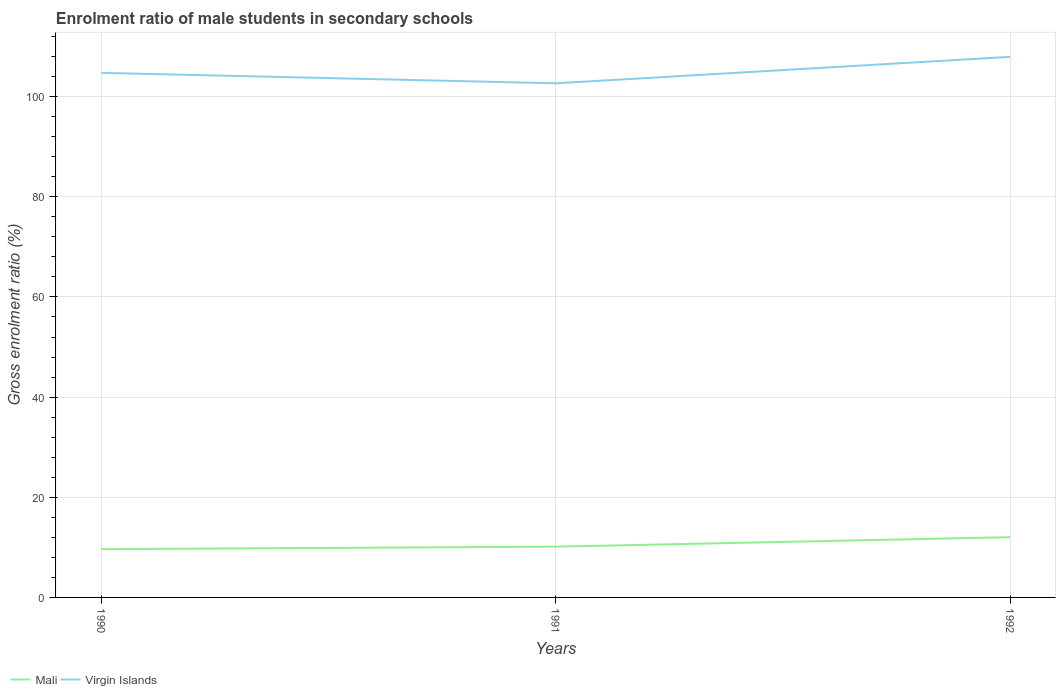How many different coloured lines are there?
Give a very brief answer. 2. Across all years, what is the maximum enrolment ratio of male students in secondary schools in Virgin Islands?
Give a very brief answer. 102.66. What is the total enrolment ratio of male students in secondary schools in Mali in the graph?
Keep it short and to the point. -0.5. What is the difference between the highest and the second highest enrolment ratio of male students in secondary schools in Mali?
Keep it short and to the point. 2.4. Does the graph contain any zero values?
Make the answer very short. No. Where does the legend appear in the graph?
Your answer should be compact. Bottom left. What is the title of the graph?
Your answer should be very brief. Enrolment ratio of male students in secondary schools. What is the label or title of the X-axis?
Offer a terse response. Years. What is the Gross enrolment ratio (%) of Mali in 1990?
Keep it short and to the point. 9.64. What is the Gross enrolment ratio (%) of Virgin Islands in 1990?
Give a very brief answer. 104.75. What is the Gross enrolment ratio (%) in Mali in 1991?
Give a very brief answer. 10.14. What is the Gross enrolment ratio (%) of Virgin Islands in 1991?
Ensure brevity in your answer.  102.66. What is the Gross enrolment ratio (%) in Mali in 1992?
Offer a very short reply. 12.03. What is the Gross enrolment ratio (%) in Virgin Islands in 1992?
Provide a short and direct response. 107.94. Across all years, what is the maximum Gross enrolment ratio (%) in Mali?
Keep it short and to the point. 12.03. Across all years, what is the maximum Gross enrolment ratio (%) of Virgin Islands?
Make the answer very short. 107.94. Across all years, what is the minimum Gross enrolment ratio (%) in Mali?
Your answer should be very brief. 9.64. Across all years, what is the minimum Gross enrolment ratio (%) of Virgin Islands?
Your answer should be compact. 102.66. What is the total Gross enrolment ratio (%) in Mali in the graph?
Your answer should be very brief. 31.81. What is the total Gross enrolment ratio (%) in Virgin Islands in the graph?
Make the answer very short. 315.36. What is the difference between the Gross enrolment ratio (%) in Mali in 1990 and that in 1991?
Make the answer very short. -0.5. What is the difference between the Gross enrolment ratio (%) of Virgin Islands in 1990 and that in 1991?
Your response must be concise. 2.09. What is the difference between the Gross enrolment ratio (%) of Mali in 1990 and that in 1992?
Your response must be concise. -2.4. What is the difference between the Gross enrolment ratio (%) in Virgin Islands in 1990 and that in 1992?
Offer a terse response. -3.19. What is the difference between the Gross enrolment ratio (%) in Mali in 1991 and that in 1992?
Your answer should be compact. -1.9. What is the difference between the Gross enrolment ratio (%) in Virgin Islands in 1991 and that in 1992?
Offer a terse response. -5.28. What is the difference between the Gross enrolment ratio (%) of Mali in 1990 and the Gross enrolment ratio (%) of Virgin Islands in 1991?
Provide a short and direct response. -93.02. What is the difference between the Gross enrolment ratio (%) of Mali in 1990 and the Gross enrolment ratio (%) of Virgin Islands in 1992?
Keep it short and to the point. -98.31. What is the difference between the Gross enrolment ratio (%) of Mali in 1991 and the Gross enrolment ratio (%) of Virgin Islands in 1992?
Offer a very short reply. -97.81. What is the average Gross enrolment ratio (%) of Mali per year?
Offer a very short reply. 10.6. What is the average Gross enrolment ratio (%) of Virgin Islands per year?
Provide a succinct answer. 105.12. In the year 1990, what is the difference between the Gross enrolment ratio (%) in Mali and Gross enrolment ratio (%) in Virgin Islands?
Offer a very short reply. -95.12. In the year 1991, what is the difference between the Gross enrolment ratio (%) of Mali and Gross enrolment ratio (%) of Virgin Islands?
Keep it short and to the point. -92.53. In the year 1992, what is the difference between the Gross enrolment ratio (%) of Mali and Gross enrolment ratio (%) of Virgin Islands?
Make the answer very short. -95.91. What is the ratio of the Gross enrolment ratio (%) in Mali in 1990 to that in 1991?
Your answer should be compact. 0.95. What is the ratio of the Gross enrolment ratio (%) of Virgin Islands in 1990 to that in 1991?
Your answer should be compact. 1.02. What is the ratio of the Gross enrolment ratio (%) of Mali in 1990 to that in 1992?
Give a very brief answer. 0.8. What is the ratio of the Gross enrolment ratio (%) in Virgin Islands in 1990 to that in 1992?
Provide a succinct answer. 0.97. What is the ratio of the Gross enrolment ratio (%) of Mali in 1991 to that in 1992?
Your response must be concise. 0.84. What is the ratio of the Gross enrolment ratio (%) in Virgin Islands in 1991 to that in 1992?
Your answer should be compact. 0.95. What is the difference between the highest and the second highest Gross enrolment ratio (%) in Mali?
Your answer should be compact. 1.9. What is the difference between the highest and the second highest Gross enrolment ratio (%) of Virgin Islands?
Keep it short and to the point. 3.19. What is the difference between the highest and the lowest Gross enrolment ratio (%) in Mali?
Offer a terse response. 2.4. What is the difference between the highest and the lowest Gross enrolment ratio (%) in Virgin Islands?
Give a very brief answer. 5.28. 